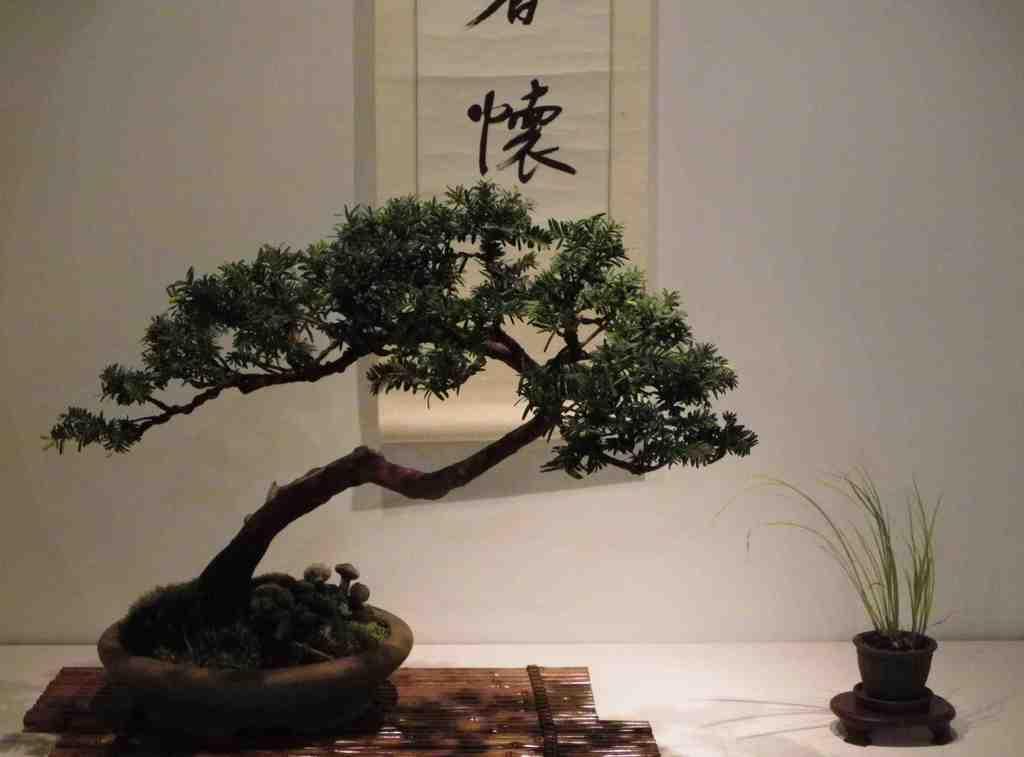Can you describe this image briefly? In the image we can see plant pot and grass pot. Here we can see the floor, wall and on the wall there is a poster. 